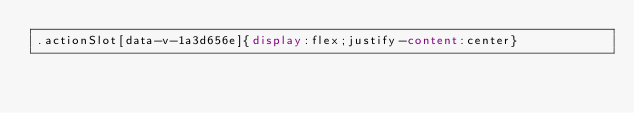Convert code to text. <code><loc_0><loc_0><loc_500><loc_500><_CSS_>.actionSlot[data-v-1a3d656e]{display:flex;justify-content:center}</code> 